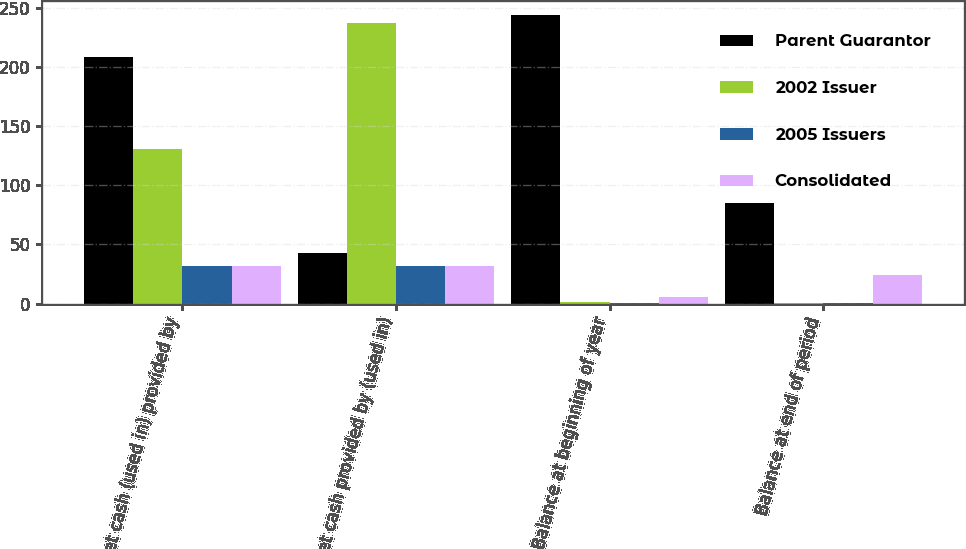<chart> <loc_0><loc_0><loc_500><loc_500><stacked_bar_chart><ecel><fcel>Net cash (used in) provided by<fcel>Net cash provided by (used in)<fcel>Balance at beginning of year<fcel>Balance at end of period<nl><fcel>Parent Guarantor<fcel>208.6<fcel>42.5<fcel>243.7<fcel>84.9<nl><fcel>2002 Issuer<fcel>130.3<fcel>236.8<fcel>1.4<fcel>0.4<nl><fcel>2005 Issuers<fcel>31.5<fcel>31.5<fcel>0.1<fcel>0.1<nl><fcel>Consolidated<fcel>31.5<fcel>31.5<fcel>5.6<fcel>24.1<nl></chart> 